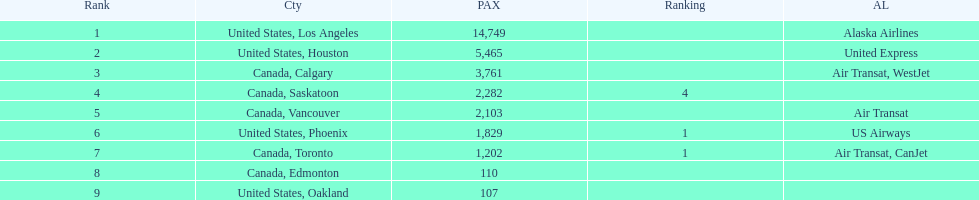The least number of passengers came from which city United States, Oakland. 